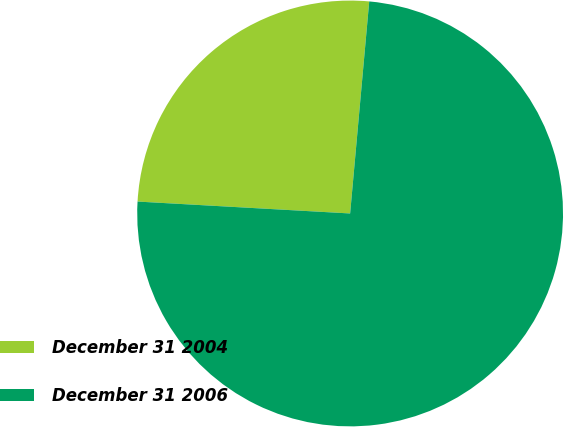Convert chart to OTSL. <chart><loc_0><loc_0><loc_500><loc_500><pie_chart><fcel>December 31 2004<fcel>December 31 2006<nl><fcel>25.54%<fcel>74.46%<nl></chart> 